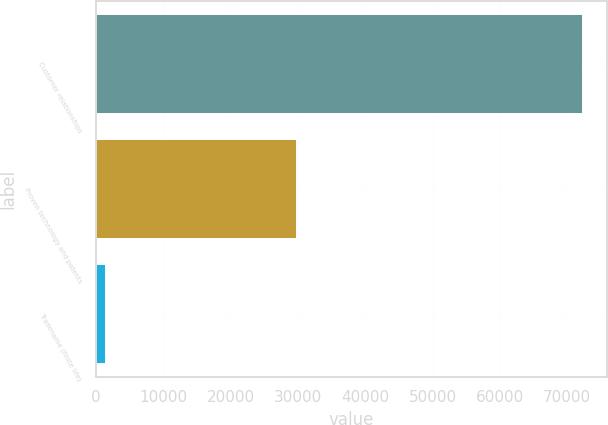Convert chart to OTSL. <chart><loc_0><loc_0><loc_500><loc_500><bar_chart><fcel>Customer relationships<fcel>Proven technology and patents<fcel>Tradename (finite life)<nl><fcel>72339<fcel>29918<fcel>1427<nl></chart> 